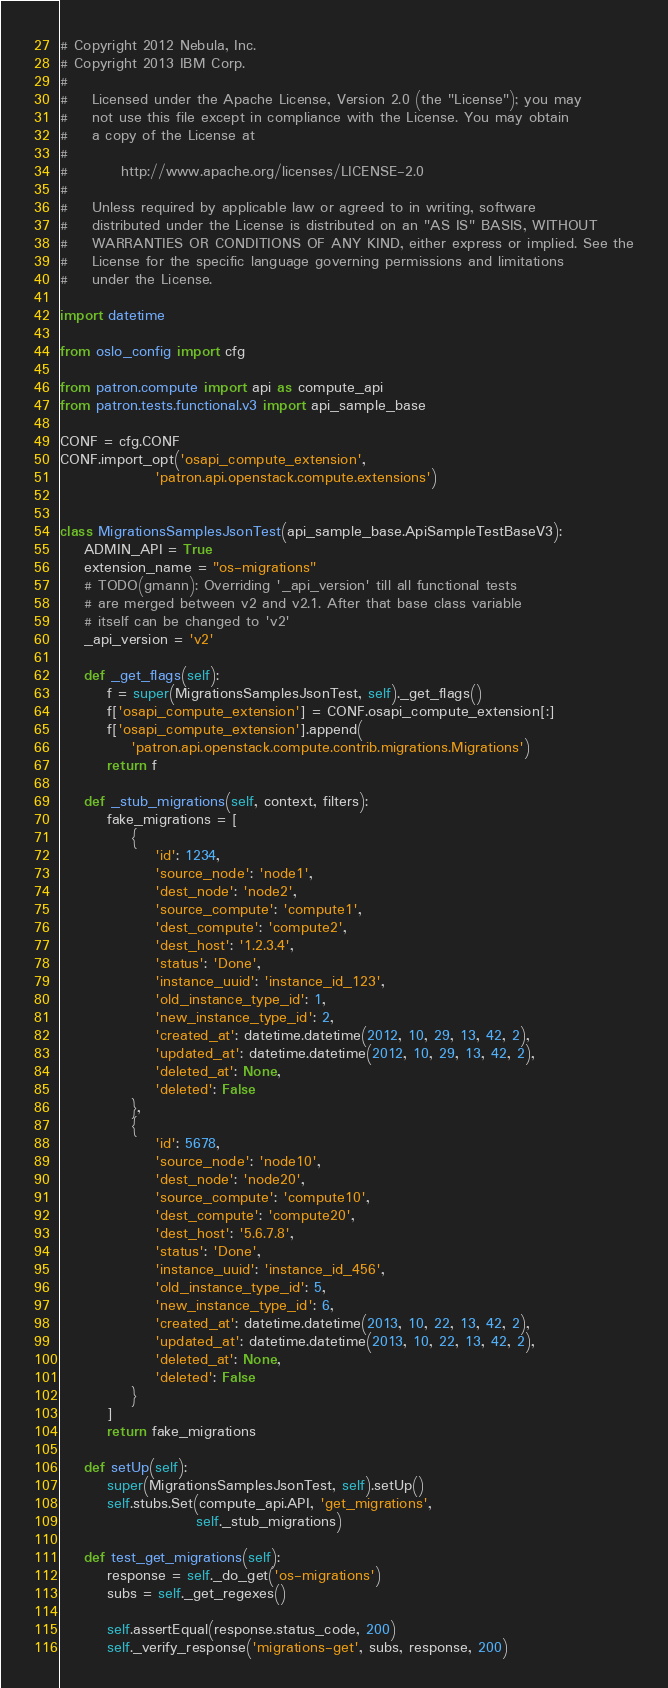Convert code to text. <code><loc_0><loc_0><loc_500><loc_500><_Python_># Copyright 2012 Nebula, Inc.
# Copyright 2013 IBM Corp.
#
#    Licensed under the Apache License, Version 2.0 (the "License"); you may
#    not use this file except in compliance with the License. You may obtain
#    a copy of the License at
#
#         http://www.apache.org/licenses/LICENSE-2.0
#
#    Unless required by applicable law or agreed to in writing, software
#    distributed under the License is distributed on an "AS IS" BASIS, WITHOUT
#    WARRANTIES OR CONDITIONS OF ANY KIND, either express or implied. See the
#    License for the specific language governing permissions and limitations
#    under the License.

import datetime

from oslo_config import cfg

from patron.compute import api as compute_api
from patron.tests.functional.v3 import api_sample_base

CONF = cfg.CONF
CONF.import_opt('osapi_compute_extension',
                'patron.api.openstack.compute.extensions')


class MigrationsSamplesJsonTest(api_sample_base.ApiSampleTestBaseV3):
    ADMIN_API = True
    extension_name = "os-migrations"
    # TODO(gmann): Overriding '_api_version' till all functional tests
    # are merged between v2 and v2.1. After that base class variable
    # itself can be changed to 'v2'
    _api_version = 'v2'

    def _get_flags(self):
        f = super(MigrationsSamplesJsonTest, self)._get_flags()
        f['osapi_compute_extension'] = CONF.osapi_compute_extension[:]
        f['osapi_compute_extension'].append(
            'patron.api.openstack.compute.contrib.migrations.Migrations')
        return f

    def _stub_migrations(self, context, filters):
        fake_migrations = [
            {
                'id': 1234,
                'source_node': 'node1',
                'dest_node': 'node2',
                'source_compute': 'compute1',
                'dest_compute': 'compute2',
                'dest_host': '1.2.3.4',
                'status': 'Done',
                'instance_uuid': 'instance_id_123',
                'old_instance_type_id': 1,
                'new_instance_type_id': 2,
                'created_at': datetime.datetime(2012, 10, 29, 13, 42, 2),
                'updated_at': datetime.datetime(2012, 10, 29, 13, 42, 2),
                'deleted_at': None,
                'deleted': False
            },
            {
                'id': 5678,
                'source_node': 'node10',
                'dest_node': 'node20',
                'source_compute': 'compute10',
                'dest_compute': 'compute20',
                'dest_host': '5.6.7.8',
                'status': 'Done',
                'instance_uuid': 'instance_id_456',
                'old_instance_type_id': 5,
                'new_instance_type_id': 6,
                'created_at': datetime.datetime(2013, 10, 22, 13, 42, 2),
                'updated_at': datetime.datetime(2013, 10, 22, 13, 42, 2),
                'deleted_at': None,
                'deleted': False
            }
        ]
        return fake_migrations

    def setUp(self):
        super(MigrationsSamplesJsonTest, self).setUp()
        self.stubs.Set(compute_api.API, 'get_migrations',
                       self._stub_migrations)

    def test_get_migrations(self):
        response = self._do_get('os-migrations')
        subs = self._get_regexes()

        self.assertEqual(response.status_code, 200)
        self._verify_response('migrations-get', subs, response, 200)
</code> 